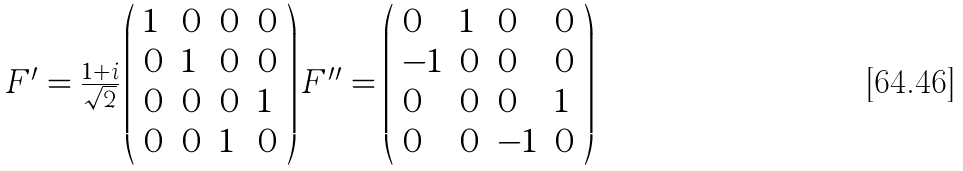<formula> <loc_0><loc_0><loc_500><loc_500>\begin{array} { c } { { F ^ { \prime } = \frac { 1 + i } { \sqrt { 2 } } \left ( \begin{array} { l l l l } { 1 } & { 0 } & { 0 } & { 0 } \\ { 0 } & { 1 } & { 0 } & { 0 } \\ { 0 } & { 0 } & { 0 } & { 1 } \\ { 0 } & { 0 } & { 1 } & { 0 } \end{array} \right ) F ^ { \prime \prime } = \left ( \begin{array} { l l l l } { 0 } & { 1 } & { 0 } & { 0 } \\ { - 1 } & { 0 } & { 0 } & { 0 } \\ { 0 } & { 0 } & { 0 } & { 1 } \\ { 0 } & { 0 } & { - 1 } & { 0 } \end{array} \right ) } } \end{array}</formula> 